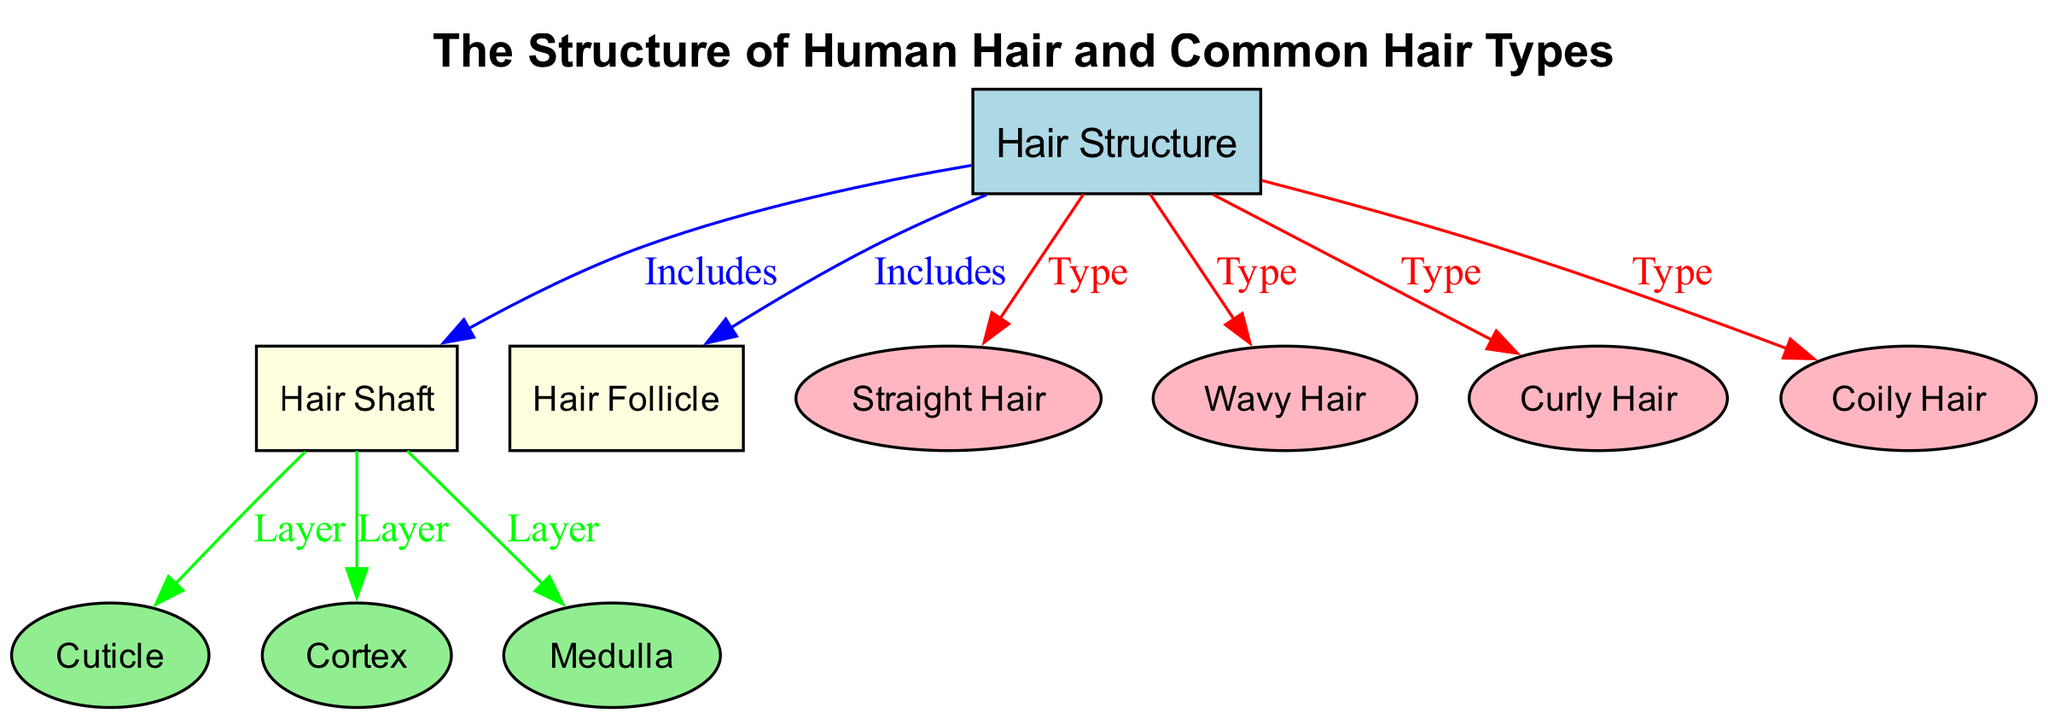What is the title of the diagram? The title is prominently displayed at the top of the diagram, providing the main topic it covers, which is "The Structure of Human Hair and Common Hair Types".
Answer: The Structure of Human Hair and Common Hair Types How many types of hair are shown in the diagram? The diagram includes four types of hair, which are explicitly listed as connections from the main structure. These types are Straight Hair, Wavy Hair, Curly Hair, and Coily Hair.
Answer: 4 Which part of the hair structure is described as a layer in the diagram? From the diagram, the edges labeled "Layer" connect to three parts: Cuticle, Cortex, and Medulla, indicating these are all considered layers within the Hair Shaft.
Answer: Cuticle, Cortex, Medulla What is the relationship between Hair Structure and Hair Follicle? The relationship is denoted by an "Includes" label, which means that within the broader context of the Hair Structure, the Hair Follicle is an important component that is included.
Answer: Includes Which part of the hair has an elliptical shape in the diagram? The nodes with an elliptical shape represent the individual layers of the hair shaft, specifically the Cuticle, Cortex, and Medulla, as indicated in their shapes.
Answer: Cuticle, Cortex, Medulla What do the colors of the nodes in the diagram indicate? The colors differentiate between various elements: light blue for the main title, light yellow for the Hair Shaft and Hair Follicle, light green for the layers (Cuticle, Cortex, Medulla), and light pink for the hair types.
Answer: Differentiate elements Which hair type is found closest to the main Hair Structure node? The hair types are connected directly from the Hair Structure node, with no specific types designated as "closer," but they are all at the same hierarchical level beneath Hair Structure.
Answer: All types equally connected How many edges are labeled as "Type" in the diagram? The edges that are labeled as "Type" connect the Hair Structure to the four hair types shown, therefore there are a total of four "Type" edges in this diagram.
Answer: 4 What is the main component included in the Hair Shaft? The main component represented in the Hair Shaft encompasses the layers which are specifically the Cuticle, Cortex, and Medulla as shown through the connections labeled "Layer".
Answer: Cuticle, Cortex, Medulla Which types of hair are represented in the diagram? The diagram specifically lists the four types of hair: Straight Hair, Wavy Hair, Curly Hair, and Coily Hair, highlighting the variety in hair textures.
Answer: Straight Hair, Wavy Hair, Curly Hair, Coily Hair 